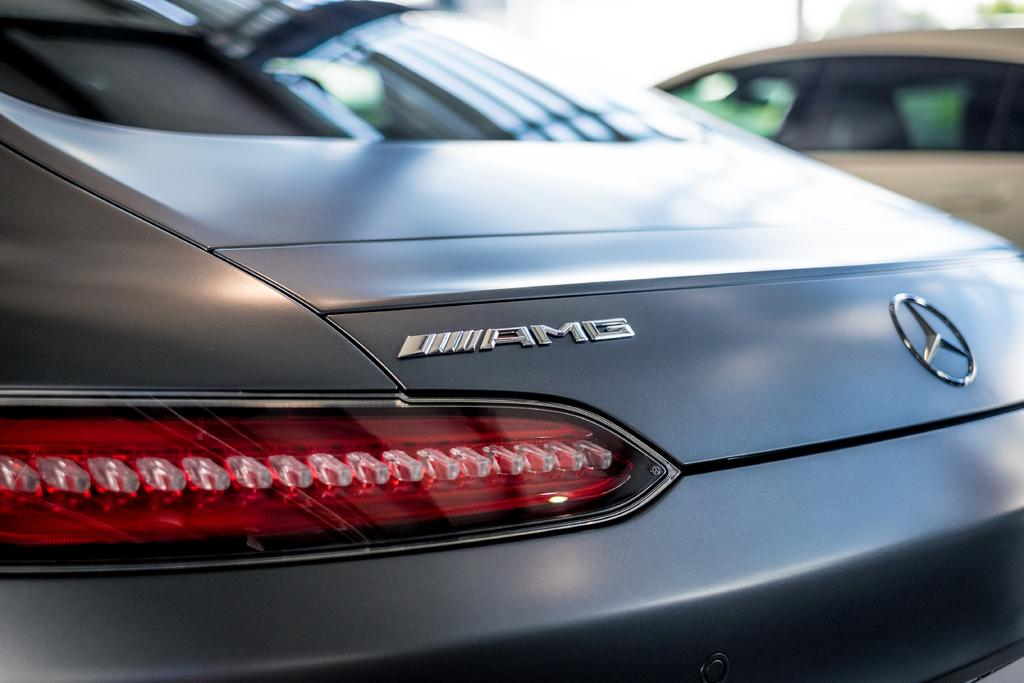What is the main subject of the image? The main subject of the image is a car. What distinguishing feature can be seen on the car? The car has a logo. What other feature is present on the car? The car has lights. Are there any other cars in the image? Yes, there is another car beside the first car. Can you tell me how many geese are standing next to the car in the image? There are no geese present in the image; it only features two cars. What type of attention is the car receiving from the rat in the image? There is no rat present in the image, and therefore no interaction with the car can be observed. 